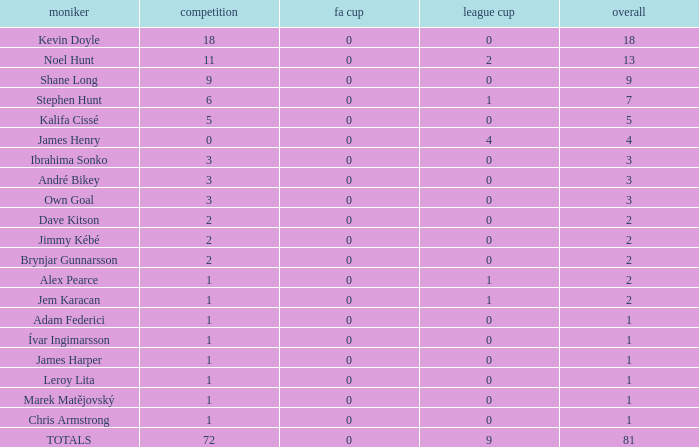Write the full table. {'header': ['moniker', 'competition', 'fa cup', 'league cup', 'overall'], 'rows': [['Kevin Doyle', '18', '0', '0', '18'], ['Noel Hunt', '11', '0', '2', '13'], ['Shane Long', '9', '0', '0', '9'], ['Stephen Hunt', '6', '0', '1', '7'], ['Kalifa Cissé', '5', '0', '0', '5'], ['James Henry', '0', '0', '4', '4'], ['Ibrahima Sonko', '3', '0', '0', '3'], ['André Bikey', '3', '0', '0', '3'], ['Own Goal', '3', '0', '0', '3'], ['Dave Kitson', '2', '0', '0', '2'], ['Jimmy Kébé', '2', '0', '0', '2'], ['Brynjar Gunnarsson', '2', '0', '0', '2'], ['Alex Pearce', '1', '0', '1', '2'], ['Jem Karacan', '1', '0', '1', '2'], ['Adam Federici', '1', '0', '0', '1'], ['Ívar Ingimarsson', '1', '0', '0', '1'], ['James Harper', '1', '0', '0', '1'], ['Leroy Lita', '1', '0', '0', '1'], ['Marek Matějovský', '1', '0', '0', '1'], ['Chris Armstrong', '1', '0', '0', '1'], ['TOTALS', '72', '0', '9', '81']]} What is the total championships that the league cup is less than 0? None. 